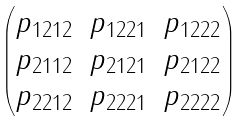Convert formula to latex. <formula><loc_0><loc_0><loc_500><loc_500>\begin{pmatrix} p _ { 1 2 1 2 } & p _ { 1 2 2 1 } & p _ { 1 2 2 2 } \\ p _ { 2 1 1 2 } & p _ { 2 1 2 1 } & p _ { 2 1 2 2 } \\ p _ { 2 2 1 2 } & p _ { 2 2 2 1 } & p _ { 2 2 2 2 } \end{pmatrix}</formula> 